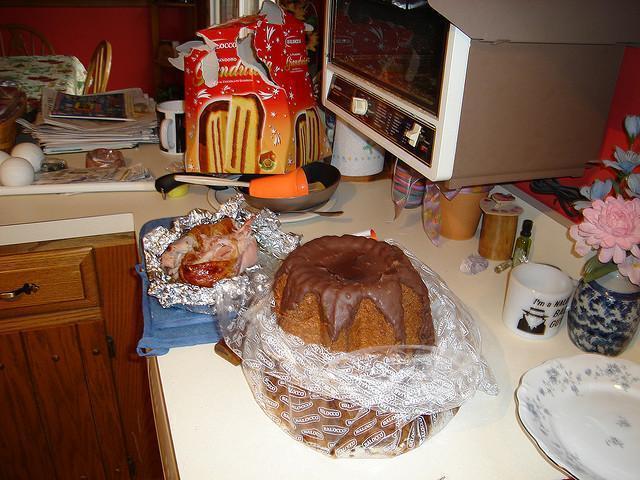What is the cake on top of?
Indicate the correct choice and explain in the format: 'Answer: answer
Rationale: rationale.'
Options: Chair, babys head, counter, pizza box. Answer: counter.
Rationale: The other options aren't in this image and would be ridiculous. 